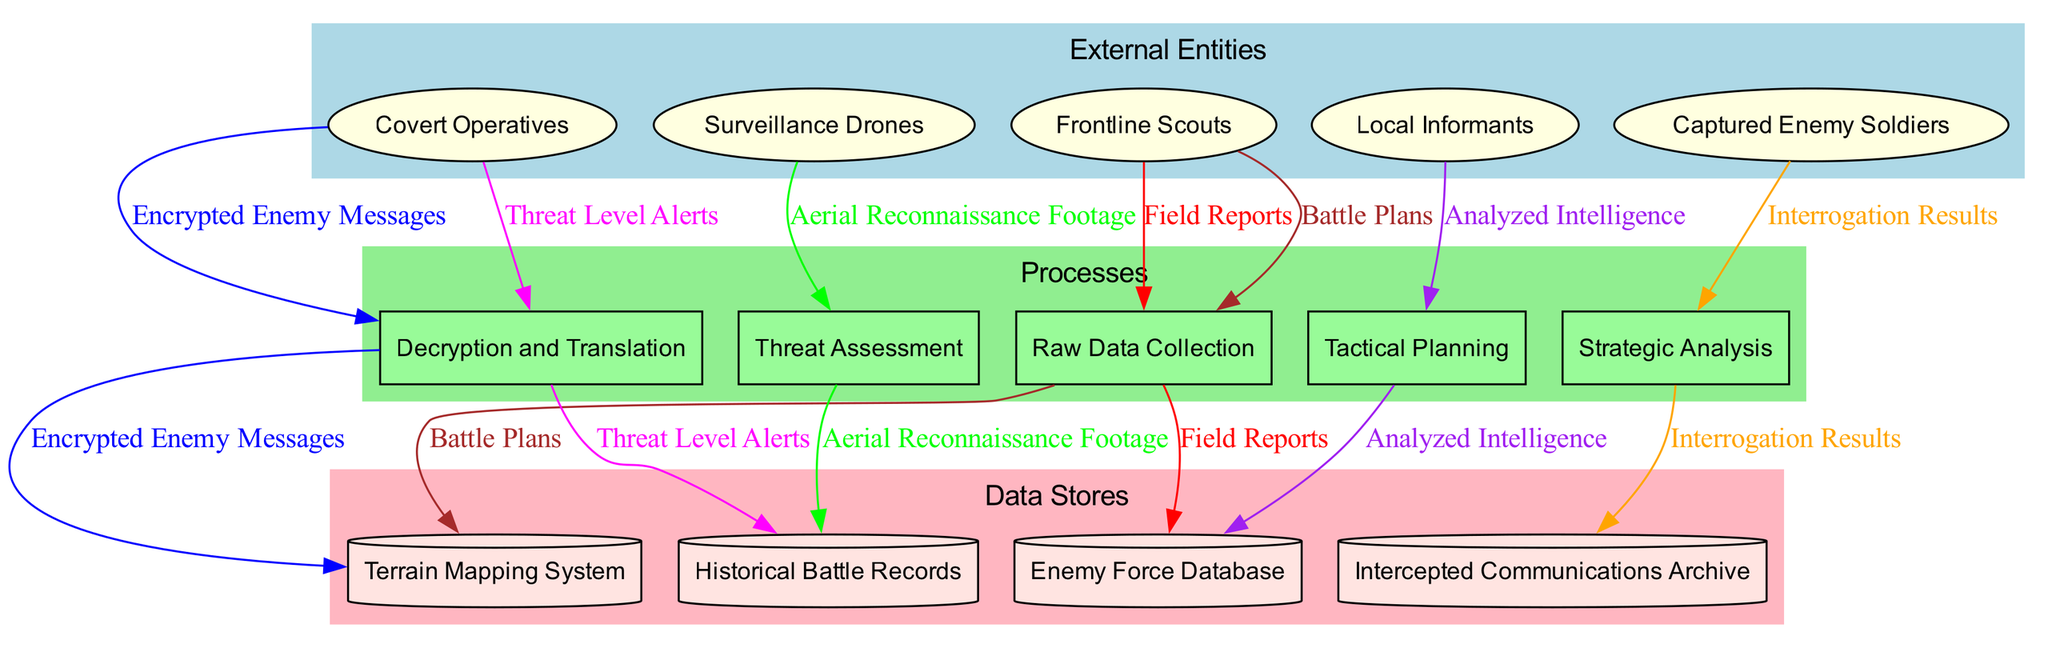What are the external entities involved in the diagram? The diagram lists five external entities: Frontline Scouts, Covert Operatives, Surveillance Drones, Captured Enemy Soldiers, and Local Informants.
Answer: Frontline Scouts, Covert Operatives, Surveillance Drones, Captured Enemy Soldiers, Local Informants How many processes are shown in the diagram? The diagram includes five processes labeled: Raw Data Collection, Decryption and Translation, Threat Assessment, Strategic Analysis, and Tactical Planning. Therefore, the total number is five.
Answer: 5 Which external entity provides Field Reports? According to the diagram, the source of Field Reports is the Frontline Scouts. This can be inferred from the data flow connections depicted in the diagram.
Answer: Frontline Scouts How many data stores are represented in the diagram? The diagram contains four data stores: Enemy Force Database, Terrain Mapping System, Historical Battle Records, and Intercepted Communications Archive. Counting these gives us four data stores.
Answer: 4 What is the flow of data from Tactical Planning to the data stores? The Tactical Planning process connects to the Enemy Force Database, Terrain Mapping System, Historical Battle Records, and Intercepted Communications Archive. This indicates that Tactical Planning's outputs can feed into these stores for further analysis.
Answer: Enemy Force Database, Terrain Mapping System, Historical Battle Records, Intercepted Communications Archive Which process receives Encrypted Enemy Messages? From the diagram, the process that receives Encrypted Enemy Messages is Decryption and Translation. This step is crucial for analyzing and understanding communications intercepted from enemies.
Answer: Decryption and Translation How are Threat Level Alerts generated in the diagram? Threat Level Alerts are derived from the Tactical Planning process. This suggests that once threats have been assessed and analyzed, appropriate alerts are formulated as a result.
Answer: Tactical Planning What type of diagram is being represented? The diagram illustrates a Data Flow Diagram which represents the flow of information and processes involved in military intelligence gathering and dissemination. This title clarifies that it's not just any diagram but specifically emphasizes data flow.
Answer: Data Flow Diagram 